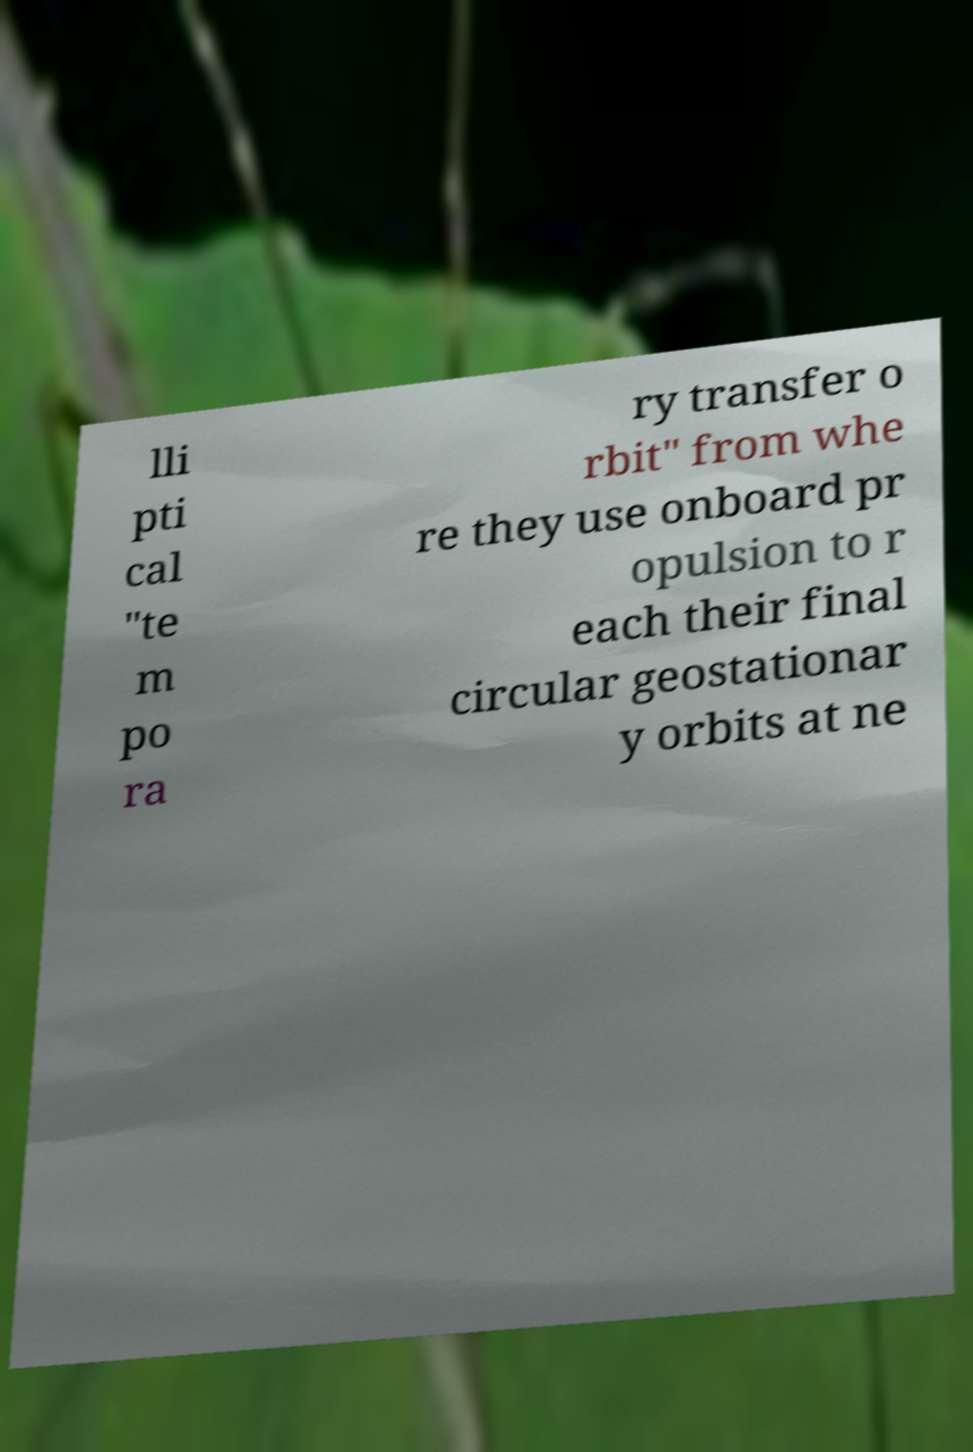What messages or text are displayed in this image? I need them in a readable, typed format. lli pti cal "te m po ra ry transfer o rbit" from whe re they use onboard pr opulsion to r each their final circular geostationar y orbits at ne 